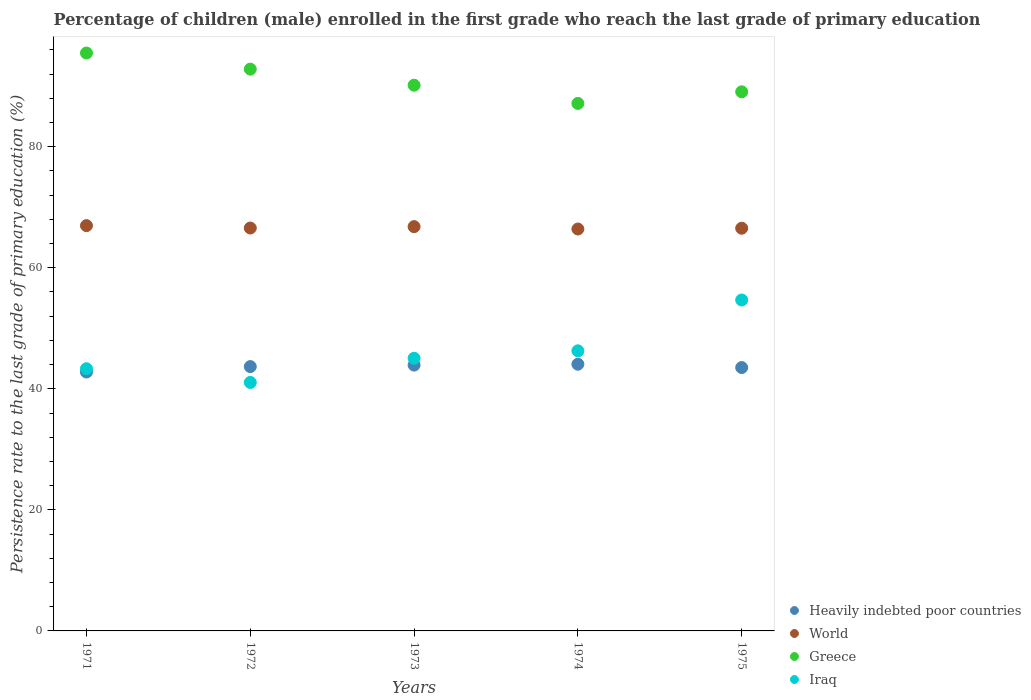What is the persistence rate of children in Iraq in 1973?
Provide a succinct answer. 45.05. Across all years, what is the maximum persistence rate of children in Greece?
Keep it short and to the point. 95.48. Across all years, what is the minimum persistence rate of children in Greece?
Provide a short and direct response. 87.15. In which year was the persistence rate of children in Iraq maximum?
Provide a succinct answer. 1975. In which year was the persistence rate of children in Greece minimum?
Give a very brief answer. 1974. What is the total persistence rate of children in Iraq in the graph?
Your response must be concise. 230.37. What is the difference between the persistence rate of children in World in 1972 and that in 1974?
Make the answer very short. 0.16. What is the difference between the persistence rate of children in Greece in 1971 and the persistence rate of children in World in 1974?
Provide a succinct answer. 29.07. What is the average persistence rate of children in World per year?
Make the answer very short. 66.65. In the year 1974, what is the difference between the persistence rate of children in Iraq and persistence rate of children in Heavily indebted poor countries?
Keep it short and to the point. 2.21. In how many years, is the persistence rate of children in Iraq greater than 76 %?
Offer a terse response. 0. What is the ratio of the persistence rate of children in Greece in 1972 to that in 1974?
Provide a succinct answer. 1.07. Is the difference between the persistence rate of children in Iraq in 1972 and 1974 greater than the difference between the persistence rate of children in Heavily indebted poor countries in 1972 and 1974?
Make the answer very short. No. What is the difference between the highest and the second highest persistence rate of children in Greece?
Make the answer very short. 2.66. What is the difference between the highest and the lowest persistence rate of children in Iraq?
Your response must be concise. 13.62. In how many years, is the persistence rate of children in Greece greater than the average persistence rate of children in Greece taken over all years?
Offer a very short reply. 2. Is it the case that in every year, the sum of the persistence rate of children in Iraq and persistence rate of children in Greece  is greater than the sum of persistence rate of children in World and persistence rate of children in Heavily indebted poor countries?
Your answer should be very brief. Yes. Does the persistence rate of children in Heavily indebted poor countries monotonically increase over the years?
Give a very brief answer. No. Is the persistence rate of children in Heavily indebted poor countries strictly less than the persistence rate of children in World over the years?
Your answer should be compact. Yes. How many dotlines are there?
Your response must be concise. 4. How many years are there in the graph?
Provide a short and direct response. 5. Are the values on the major ticks of Y-axis written in scientific E-notation?
Your answer should be very brief. No. Does the graph contain grids?
Provide a succinct answer. No. How many legend labels are there?
Your answer should be compact. 4. What is the title of the graph?
Make the answer very short. Percentage of children (male) enrolled in the first grade who reach the last grade of primary education. What is the label or title of the Y-axis?
Make the answer very short. Persistence rate to the last grade of primary education (%). What is the Persistence rate to the last grade of primary education (%) of Heavily indebted poor countries in 1971?
Give a very brief answer. 42.78. What is the Persistence rate to the last grade of primary education (%) in World in 1971?
Your answer should be very brief. 66.96. What is the Persistence rate to the last grade of primary education (%) of Greece in 1971?
Make the answer very short. 95.48. What is the Persistence rate to the last grade of primary education (%) in Iraq in 1971?
Keep it short and to the point. 43.32. What is the Persistence rate to the last grade of primary education (%) of Heavily indebted poor countries in 1972?
Your response must be concise. 43.67. What is the Persistence rate to the last grade of primary education (%) of World in 1972?
Offer a terse response. 66.57. What is the Persistence rate to the last grade of primary education (%) in Greece in 1972?
Your answer should be compact. 92.82. What is the Persistence rate to the last grade of primary education (%) in Iraq in 1972?
Make the answer very short. 41.05. What is the Persistence rate to the last grade of primary education (%) of Heavily indebted poor countries in 1973?
Give a very brief answer. 43.92. What is the Persistence rate to the last grade of primary education (%) of World in 1973?
Offer a terse response. 66.8. What is the Persistence rate to the last grade of primary education (%) of Greece in 1973?
Keep it short and to the point. 90.16. What is the Persistence rate to the last grade of primary education (%) in Iraq in 1973?
Provide a short and direct response. 45.05. What is the Persistence rate to the last grade of primary education (%) in Heavily indebted poor countries in 1974?
Your answer should be very brief. 44.07. What is the Persistence rate to the last grade of primary education (%) in World in 1974?
Your response must be concise. 66.41. What is the Persistence rate to the last grade of primary education (%) of Greece in 1974?
Your answer should be compact. 87.15. What is the Persistence rate to the last grade of primary education (%) in Iraq in 1974?
Make the answer very short. 46.28. What is the Persistence rate to the last grade of primary education (%) in Heavily indebted poor countries in 1975?
Provide a succinct answer. 43.51. What is the Persistence rate to the last grade of primary education (%) in World in 1975?
Offer a terse response. 66.53. What is the Persistence rate to the last grade of primary education (%) in Greece in 1975?
Make the answer very short. 89.07. What is the Persistence rate to the last grade of primary education (%) of Iraq in 1975?
Your answer should be compact. 54.68. Across all years, what is the maximum Persistence rate to the last grade of primary education (%) in Heavily indebted poor countries?
Ensure brevity in your answer.  44.07. Across all years, what is the maximum Persistence rate to the last grade of primary education (%) in World?
Make the answer very short. 66.96. Across all years, what is the maximum Persistence rate to the last grade of primary education (%) in Greece?
Give a very brief answer. 95.48. Across all years, what is the maximum Persistence rate to the last grade of primary education (%) in Iraq?
Ensure brevity in your answer.  54.68. Across all years, what is the minimum Persistence rate to the last grade of primary education (%) of Heavily indebted poor countries?
Provide a succinct answer. 42.78. Across all years, what is the minimum Persistence rate to the last grade of primary education (%) of World?
Provide a short and direct response. 66.41. Across all years, what is the minimum Persistence rate to the last grade of primary education (%) of Greece?
Your response must be concise. 87.15. Across all years, what is the minimum Persistence rate to the last grade of primary education (%) in Iraq?
Your answer should be compact. 41.05. What is the total Persistence rate to the last grade of primary education (%) of Heavily indebted poor countries in the graph?
Provide a succinct answer. 217.95. What is the total Persistence rate to the last grade of primary education (%) of World in the graph?
Make the answer very short. 333.26. What is the total Persistence rate to the last grade of primary education (%) in Greece in the graph?
Give a very brief answer. 454.68. What is the total Persistence rate to the last grade of primary education (%) of Iraq in the graph?
Provide a short and direct response. 230.37. What is the difference between the Persistence rate to the last grade of primary education (%) in Heavily indebted poor countries in 1971 and that in 1972?
Keep it short and to the point. -0.89. What is the difference between the Persistence rate to the last grade of primary education (%) of World in 1971 and that in 1972?
Keep it short and to the point. 0.39. What is the difference between the Persistence rate to the last grade of primary education (%) in Greece in 1971 and that in 1972?
Your response must be concise. 2.66. What is the difference between the Persistence rate to the last grade of primary education (%) of Iraq in 1971 and that in 1972?
Your answer should be very brief. 2.26. What is the difference between the Persistence rate to the last grade of primary education (%) of Heavily indebted poor countries in 1971 and that in 1973?
Ensure brevity in your answer.  -1.14. What is the difference between the Persistence rate to the last grade of primary education (%) of World in 1971 and that in 1973?
Provide a short and direct response. 0.16. What is the difference between the Persistence rate to the last grade of primary education (%) of Greece in 1971 and that in 1973?
Your response must be concise. 5.31. What is the difference between the Persistence rate to the last grade of primary education (%) in Iraq in 1971 and that in 1973?
Your answer should be compact. -1.73. What is the difference between the Persistence rate to the last grade of primary education (%) of Heavily indebted poor countries in 1971 and that in 1974?
Your answer should be very brief. -1.29. What is the difference between the Persistence rate to the last grade of primary education (%) in World in 1971 and that in 1974?
Ensure brevity in your answer.  0.56. What is the difference between the Persistence rate to the last grade of primary education (%) of Greece in 1971 and that in 1974?
Your response must be concise. 8.32. What is the difference between the Persistence rate to the last grade of primary education (%) in Iraq in 1971 and that in 1974?
Keep it short and to the point. -2.96. What is the difference between the Persistence rate to the last grade of primary education (%) in Heavily indebted poor countries in 1971 and that in 1975?
Your answer should be very brief. -0.73. What is the difference between the Persistence rate to the last grade of primary education (%) in World in 1971 and that in 1975?
Keep it short and to the point. 0.43. What is the difference between the Persistence rate to the last grade of primary education (%) of Greece in 1971 and that in 1975?
Offer a terse response. 6.41. What is the difference between the Persistence rate to the last grade of primary education (%) of Iraq in 1971 and that in 1975?
Ensure brevity in your answer.  -11.36. What is the difference between the Persistence rate to the last grade of primary education (%) of Heavily indebted poor countries in 1972 and that in 1973?
Your answer should be compact. -0.25. What is the difference between the Persistence rate to the last grade of primary education (%) of World in 1972 and that in 1973?
Your response must be concise. -0.23. What is the difference between the Persistence rate to the last grade of primary education (%) in Greece in 1972 and that in 1973?
Your response must be concise. 2.66. What is the difference between the Persistence rate to the last grade of primary education (%) in Iraq in 1972 and that in 1973?
Ensure brevity in your answer.  -3.99. What is the difference between the Persistence rate to the last grade of primary education (%) in Heavily indebted poor countries in 1972 and that in 1974?
Your answer should be compact. -0.39. What is the difference between the Persistence rate to the last grade of primary education (%) in World in 1972 and that in 1974?
Provide a short and direct response. 0.16. What is the difference between the Persistence rate to the last grade of primary education (%) of Greece in 1972 and that in 1974?
Ensure brevity in your answer.  5.67. What is the difference between the Persistence rate to the last grade of primary education (%) of Iraq in 1972 and that in 1974?
Keep it short and to the point. -5.22. What is the difference between the Persistence rate to the last grade of primary education (%) of Heavily indebted poor countries in 1972 and that in 1975?
Your answer should be compact. 0.16. What is the difference between the Persistence rate to the last grade of primary education (%) of World in 1972 and that in 1975?
Your response must be concise. 0.04. What is the difference between the Persistence rate to the last grade of primary education (%) in Greece in 1972 and that in 1975?
Your answer should be compact. 3.75. What is the difference between the Persistence rate to the last grade of primary education (%) of Iraq in 1972 and that in 1975?
Give a very brief answer. -13.62. What is the difference between the Persistence rate to the last grade of primary education (%) of Heavily indebted poor countries in 1973 and that in 1974?
Your answer should be compact. -0.15. What is the difference between the Persistence rate to the last grade of primary education (%) in World in 1973 and that in 1974?
Give a very brief answer. 0.39. What is the difference between the Persistence rate to the last grade of primary education (%) in Greece in 1973 and that in 1974?
Your answer should be compact. 3.01. What is the difference between the Persistence rate to the last grade of primary education (%) in Iraq in 1973 and that in 1974?
Your answer should be compact. -1.23. What is the difference between the Persistence rate to the last grade of primary education (%) in Heavily indebted poor countries in 1973 and that in 1975?
Offer a terse response. 0.41. What is the difference between the Persistence rate to the last grade of primary education (%) of World in 1973 and that in 1975?
Make the answer very short. 0.26. What is the difference between the Persistence rate to the last grade of primary education (%) in Greece in 1973 and that in 1975?
Make the answer very short. 1.09. What is the difference between the Persistence rate to the last grade of primary education (%) of Iraq in 1973 and that in 1975?
Give a very brief answer. -9.63. What is the difference between the Persistence rate to the last grade of primary education (%) in Heavily indebted poor countries in 1974 and that in 1975?
Make the answer very short. 0.56. What is the difference between the Persistence rate to the last grade of primary education (%) in World in 1974 and that in 1975?
Provide a succinct answer. -0.13. What is the difference between the Persistence rate to the last grade of primary education (%) of Greece in 1974 and that in 1975?
Make the answer very short. -1.92. What is the difference between the Persistence rate to the last grade of primary education (%) in Iraq in 1974 and that in 1975?
Your answer should be very brief. -8.4. What is the difference between the Persistence rate to the last grade of primary education (%) in Heavily indebted poor countries in 1971 and the Persistence rate to the last grade of primary education (%) in World in 1972?
Your answer should be compact. -23.79. What is the difference between the Persistence rate to the last grade of primary education (%) in Heavily indebted poor countries in 1971 and the Persistence rate to the last grade of primary education (%) in Greece in 1972?
Your answer should be very brief. -50.04. What is the difference between the Persistence rate to the last grade of primary education (%) in Heavily indebted poor countries in 1971 and the Persistence rate to the last grade of primary education (%) in Iraq in 1972?
Keep it short and to the point. 1.72. What is the difference between the Persistence rate to the last grade of primary education (%) of World in 1971 and the Persistence rate to the last grade of primary education (%) of Greece in 1972?
Your response must be concise. -25.86. What is the difference between the Persistence rate to the last grade of primary education (%) of World in 1971 and the Persistence rate to the last grade of primary education (%) of Iraq in 1972?
Your response must be concise. 25.91. What is the difference between the Persistence rate to the last grade of primary education (%) in Greece in 1971 and the Persistence rate to the last grade of primary education (%) in Iraq in 1972?
Offer a terse response. 54.42. What is the difference between the Persistence rate to the last grade of primary education (%) of Heavily indebted poor countries in 1971 and the Persistence rate to the last grade of primary education (%) of World in 1973?
Your answer should be very brief. -24.02. What is the difference between the Persistence rate to the last grade of primary education (%) in Heavily indebted poor countries in 1971 and the Persistence rate to the last grade of primary education (%) in Greece in 1973?
Your answer should be compact. -47.38. What is the difference between the Persistence rate to the last grade of primary education (%) of Heavily indebted poor countries in 1971 and the Persistence rate to the last grade of primary education (%) of Iraq in 1973?
Give a very brief answer. -2.27. What is the difference between the Persistence rate to the last grade of primary education (%) of World in 1971 and the Persistence rate to the last grade of primary education (%) of Greece in 1973?
Provide a short and direct response. -23.2. What is the difference between the Persistence rate to the last grade of primary education (%) of World in 1971 and the Persistence rate to the last grade of primary education (%) of Iraq in 1973?
Keep it short and to the point. 21.91. What is the difference between the Persistence rate to the last grade of primary education (%) of Greece in 1971 and the Persistence rate to the last grade of primary education (%) of Iraq in 1973?
Your response must be concise. 50.43. What is the difference between the Persistence rate to the last grade of primary education (%) of Heavily indebted poor countries in 1971 and the Persistence rate to the last grade of primary education (%) of World in 1974?
Ensure brevity in your answer.  -23.63. What is the difference between the Persistence rate to the last grade of primary education (%) in Heavily indebted poor countries in 1971 and the Persistence rate to the last grade of primary education (%) in Greece in 1974?
Give a very brief answer. -44.37. What is the difference between the Persistence rate to the last grade of primary education (%) of Heavily indebted poor countries in 1971 and the Persistence rate to the last grade of primary education (%) of Iraq in 1974?
Your answer should be very brief. -3.5. What is the difference between the Persistence rate to the last grade of primary education (%) in World in 1971 and the Persistence rate to the last grade of primary education (%) in Greece in 1974?
Keep it short and to the point. -20.19. What is the difference between the Persistence rate to the last grade of primary education (%) in World in 1971 and the Persistence rate to the last grade of primary education (%) in Iraq in 1974?
Make the answer very short. 20.68. What is the difference between the Persistence rate to the last grade of primary education (%) of Greece in 1971 and the Persistence rate to the last grade of primary education (%) of Iraq in 1974?
Provide a short and direct response. 49.2. What is the difference between the Persistence rate to the last grade of primary education (%) of Heavily indebted poor countries in 1971 and the Persistence rate to the last grade of primary education (%) of World in 1975?
Your answer should be very brief. -23.75. What is the difference between the Persistence rate to the last grade of primary education (%) in Heavily indebted poor countries in 1971 and the Persistence rate to the last grade of primary education (%) in Greece in 1975?
Your answer should be very brief. -46.29. What is the difference between the Persistence rate to the last grade of primary education (%) in Heavily indebted poor countries in 1971 and the Persistence rate to the last grade of primary education (%) in Iraq in 1975?
Give a very brief answer. -11.9. What is the difference between the Persistence rate to the last grade of primary education (%) of World in 1971 and the Persistence rate to the last grade of primary education (%) of Greece in 1975?
Offer a terse response. -22.11. What is the difference between the Persistence rate to the last grade of primary education (%) in World in 1971 and the Persistence rate to the last grade of primary education (%) in Iraq in 1975?
Provide a short and direct response. 12.29. What is the difference between the Persistence rate to the last grade of primary education (%) of Greece in 1971 and the Persistence rate to the last grade of primary education (%) of Iraq in 1975?
Provide a succinct answer. 40.8. What is the difference between the Persistence rate to the last grade of primary education (%) of Heavily indebted poor countries in 1972 and the Persistence rate to the last grade of primary education (%) of World in 1973?
Ensure brevity in your answer.  -23.12. What is the difference between the Persistence rate to the last grade of primary education (%) in Heavily indebted poor countries in 1972 and the Persistence rate to the last grade of primary education (%) in Greece in 1973?
Your answer should be very brief. -46.49. What is the difference between the Persistence rate to the last grade of primary education (%) of Heavily indebted poor countries in 1972 and the Persistence rate to the last grade of primary education (%) of Iraq in 1973?
Provide a succinct answer. -1.37. What is the difference between the Persistence rate to the last grade of primary education (%) of World in 1972 and the Persistence rate to the last grade of primary education (%) of Greece in 1973?
Keep it short and to the point. -23.6. What is the difference between the Persistence rate to the last grade of primary education (%) in World in 1972 and the Persistence rate to the last grade of primary education (%) in Iraq in 1973?
Ensure brevity in your answer.  21.52. What is the difference between the Persistence rate to the last grade of primary education (%) in Greece in 1972 and the Persistence rate to the last grade of primary education (%) in Iraq in 1973?
Make the answer very short. 47.77. What is the difference between the Persistence rate to the last grade of primary education (%) of Heavily indebted poor countries in 1972 and the Persistence rate to the last grade of primary education (%) of World in 1974?
Your response must be concise. -22.73. What is the difference between the Persistence rate to the last grade of primary education (%) in Heavily indebted poor countries in 1972 and the Persistence rate to the last grade of primary education (%) in Greece in 1974?
Keep it short and to the point. -43.48. What is the difference between the Persistence rate to the last grade of primary education (%) in Heavily indebted poor countries in 1972 and the Persistence rate to the last grade of primary education (%) in Iraq in 1974?
Provide a short and direct response. -2.61. What is the difference between the Persistence rate to the last grade of primary education (%) of World in 1972 and the Persistence rate to the last grade of primary education (%) of Greece in 1974?
Ensure brevity in your answer.  -20.59. What is the difference between the Persistence rate to the last grade of primary education (%) in World in 1972 and the Persistence rate to the last grade of primary education (%) in Iraq in 1974?
Ensure brevity in your answer.  20.29. What is the difference between the Persistence rate to the last grade of primary education (%) of Greece in 1972 and the Persistence rate to the last grade of primary education (%) of Iraq in 1974?
Offer a very short reply. 46.54. What is the difference between the Persistence rate to the last grade of primary education (%) in Heavily indebted poor countries in 1972 and the Persistence rate to the last grade of primary education (%) in World in 1975?
Your response must be concise. -22.86. What is the difference between the Persistence rate to the last grade of primary education (%) of Heavily indebted poor countries in 1972 and the Persistence rate to the last grade of primary education (%) of Greece in 1975?
Your response must be concise. -45.4. What is the difference between the Persistence rate to the last grade of primary education (%) in Heavily indebted poor countries in 1972 and the Persistence rate to the last grade of primary education (%) in Iraq in 1975?
Make the answer very short. -11. What is the difference between the Persistence rate to the last grade of primary education (%) of World in 1972 and the Persistence rate to the last grade of primary education (%) of Greece in 1975?
Keep it short and to the point. -22.5. What is the difference between the Persistence rate to the last grade of primary education (%) in World in 1972 and the Persistence rate to the last grade of primary education (%) in Iraq in 1975?
Your answer should be compact. 11.89. What is the difference between the Persistence rate to the last grade of primary education (%) in Greece in 1972 and the Persistence rate to the last grade of primary education (%) in Iraq in 1975?
Make the answer very short. 38.14. What is the difference between the Persistence rate to the last grade of primary education (%) in Heavily indebted poor countries in 1973 and the Persistence rate to the last grade of primary education (%) in World in 1974?
Provide a succinct answer. -22.49. What is the difference between the Persistence rate to the last grade of primary education (%) of Heavily indebted poor countries in 1973 and the Persistence rate to the last grade of primary education (%) of Greece in 1974?
Offer a terse response. -43.24. What is the difference between the Persistence rate to the last grade of primary education (%) of Heavily indebted poor countries in 1973 and the Persistence rate to the last grade of primary education (%) of Iraq in 1974?
Give a very brief answer. -2.36. What is the difference between the Persistence rate to the last grade of primary education (%) of World in 1973 and the Persistence rate to the last grade of primary education (%) of Greece in 1974?
Provide a short and direct response. -20.36. What is the difference between the Persistence rate to the last grade of primary education (%) in World in 1973 and the Persistence rate to the last grade of primary education (%) in Iraq in 1974?
Offer a very short reply. 20.52. What is the difference between the Persistence rate to the last grade of primary education (%) of Greece in 1973 and the Persistence rate to the last grade of primary education (%) of Iraq in 1974?
Your answer should be compact. 43.88. What is the difference between the Persistence rate to the last grade of primary education (%) in Heavily indebted poor countries in 1973 and the Persistence rate to the last grade of primary education (%) in World in 1975?
Provide a short and direct response. -22.61. What is the difference between the Persistence rate to the last grade of primary education (%) in Heavily indebted poor countries in 1973 and the Persistence rate to the last grade of primary education (%) in Greece in 1975?
Your answer should be very brief. -45.15. What is the difference between the Persistence rate to the last grade of primary education (%) in Heavily indebted poor countries in 1973 and the Persistence rate to the last grade of primary education (%) in Iraq in 1975?
Your answer should be compact. -10.76. What is the difference between the Persistence rate to the last grade of primary education (%) of World in 1973 and the Persistence rate to the last grade of primary education (%) of Greece in 1975?
Your answer should be very brief. -22.27. What is the difference between the Persistence rate to the last grade of primary education (%) in World in 1973 and the Persistence rate to the last grade of primary education (%) in Iraq in 1975?
Offer a very short reply. 12.12. What is the difference between the Persistence rate to the last grade of primary education (%) in Greece in 1973 and the Persistence rate to the last grade of primary education (%) in Iraq in 1975?
Keep it short and to the point. 35.49. What is the difference between the Persistence rate to the last grade of primary education (%) of Heavily indebted poor countries in 1974 and the Persistence rate to the last grade of primary education (%) of World in 1975?
Provide a succinct answer. -22.47. What is the difference between the Persistence rate to the last grade of primary education (%) in Heavily indebted poor countries in 1974 and the Persistence rate to the last grade of primary education (%) in Greece in 1975?
Offer a very short reply. -45. What is the difference between the Persistence rate to the last grade of primary education (%) of Heavily indebted poor countries in 1974 and the Persistence rate to the last grade of primary education (%) of Iraq in 1975?
Provide a short and direct response. -10.61. What is the difference between the Persistence rate to the last grade of primary education (%) of World in 1974 and the Persistence rate to the last grade of primary education (%) of Greece in 1975?
Keep it short and to the point. -22.67. What is the difference between the Persistence rate to the last grade of primary education (%) in World in 1974 and the Persistence rate to the last grade of primary education (%) in Iraq in 1975?
Your response must be concise. 11.73. What is the difference between the Persistence rate to the last grade of primary education (%) in Greece in 1974 and the Persistence rate to the last grade of primary education (%) in Iraq in 1975?
Provide a succinct answer. 32.48. What is the average Persistence rate to the last grade of primary education (%) of Heavily indebted poor countries per year?
Your answer should be very brief. 43.59. What is the average Persistence rate to the last grade of primary education (%) of World per year?
Give a very brief answer. 66.65. What is the average Persistence rate to the last grade of primary education (%) of Greece per year?
Provide a succinct answer. 90.94. What is the average Persistence rate to the last grade of primary education (%) of Iraq per year?
Your answer should be very brief. 46.07. In the year 1971, what is the difference between the Persistence rate to the last grade of primary education (%) of Heavily indebted poor countries and Persistence rate to the last grade of primary education (%) of World?
Offer a very short reply. -24.18. In the year 1971, what is the difference between the Persistence rate to the last grade of primary education (%) in Heavily indebted poor countries and Persistence rate to the last grade of primary education (%) in Greece?
Give a very brief answer. -52.7. In the year 1971, what is the difference between the Persistence rate to the last grade of primary education (%) of Heavily indebted poor countries and Persistence rate to the last grade of primary education (%) of Iraq?
Make the answer very short. -0.54. In the year 1971, what is the difference between the Persistence rate to the last grade of primary education (%) in World and Persistence rate to the last grade of primary education (%) in Greece?
Offer a very short reply. -28.52. In the year 1971, what is the difference between the Persistence rate to the last grade of primary education (%) in World and Persistence rate to the last grade of primary education (%) in Iraq?
Offer a very short reply. 23.64. In the year 1971, what is the difference between the Persistence rate to the last grade of primary education (%) in Greece and Persistence rate to the last grade of primary education (%) in Iraq?
Give a very brief answer. 52.16. In the year 1972, what is the difference between the Persistence rate to the last grade of primary education (%) of Heavily indebted poor countries and Persistence rate to the last grade of primary education (%) of World?
Provide a succinct answer. -22.89. In the year 1972, what is the difference between the Persistence rate to the last grade of primary education (%) of Heavily indebted poor countries and Persistence rate to the last grade of primary education (%) of Greece?
Make the answer very short. -49.15. In the year 1972, what is the difference between the Persistence rate to the last grade of primary education (%) in Heavily indebted poor countries and Persistence rate to the last grade of primary education (%) in Iraq?
Your response must be concise. 2.62. In the year 1972, what is the difference between the Persistence rate to the last grade of primary education (%) of World and Persistence rate to the last grade of primary education (%) of Greece?
Keep it short and to the point. -26.25. In the year 1972, what is the difference between the Persistence rate to the last grade of primary education (%) of World and Persistence rate to the last grade of primary education (%) of Iraq?
Ensure brevity in your answer.  25.51. In the year 1972, what is the difference between the Persistence rate to the last grade of primary education (%) in Greece and Persistence rate to the last grade of primary education (%) in Iraq?
Make the answer very short. 51.77. In the year 1973, what is the difference between the Persistence rate to the last grade of primary education (%) of Heavily indebted poor countries and Persistence rate to the last grade of primary education (%) of World?
Offer a very short reply. -22.88. In the year 1973, what is the difference between the Persistence rate to the last grade of primary education (%) of Heavily indebted poor countries and Persistence rate to the last grade of primary education (%) of Greece?
Offer a very short reply. -46.24. In the year 1973, what is the difference between the Persistence rate to the last grade of primary education (%) in Heavily indebted poor countries and Persistence rate to the last grade of primary education (%) in Iraq?
Your response must be concise. -1.13. In the year 1973, what is the difference between the Persistence rate to the last grade of primary education (%) in World and Persistence rate to the last grade of primary education (%) in Greece?
Ensure brevity in your answer.  -23.37. In the year 1973, what is the difference between the Persistence rate to the last grade of primary education (%) of World and Persistence rate to the last grade of primary education (%) of Iraq?
Your response must be concise. 21.75. In the year 1973, what is the difference between the Persistence rate to the last grade of primary education (%) of Greece and Persistence rate to the last grade of primary education (%) of Iraq?
Ensure brevity in your answer.  45.12. In the year 1974, what is the difference between the Persistence rate to the last grade of primary education (%) in Heavily indebted poor countries and Persistence rate to the last grade of primary education (%) in World?
Offer a very short reply. -22.34. In the year 1974, what is the difference between the Persistence rate to the last grade of primary education (%) of Heavily indebted poor countries and Persistence rate to the last grade of primary education (%) of Greece?
Give a very brief answer. -43.09. In the year 1974, what is the difference between the Persistence rate to the last grade of primary education (%) of Heavily indebted poor countries and Persistence rate to the last grade of primary education (%) of Iraq?
Offer a very short reply. -2.21. In the year 1974, what is the difference between the Persistence rate to the last grade of primary education (%) in World and Persistence rate to the last grade of primary education (%) in Greece?
Provide a succinct answer. -20.75. In the year 1974, what is the difference between the Persistence rate to the last grade of primary education (%) of World and Persistence rate to the last grade of primary education (%) of Iraq?
Provide a short and direct response. 20.13. In the year 1974, what is the difference between the Persistence rate to the last grade of primary education (%) of Greece and Persistence rate to the last grade of primary education (%) of Iraq?
Offer a very short reply. 40.87. In the year 1975, what is the difference between the Persistence rate to the last grade of primary education (%) of Heavily indebted poor countries and Persistence rate to the last grade of primary education (%) of World?
Your answer should be compact. -23.02. In the year 1975, what is the difference between the Persistence rate to the last grade of primary education (%) in Heavily indebted poor countries and Persistence rate to the last grade of primary education (%) in Greece?
Provide a short and direct response. -45.56. In the year 1975, what is the difference between the Persistence rate to the last grade of primary education (%) in Heavily indebted poor countries and Persistence rate to the last grade of primary education (%) in Iraq?
Provide a succinct answer. -11.16. In the year 1975, what is the difference between the Persistence rate to the last grade of primary education (%) in World and Persistence rate to the last grade of primary education (%) in Greece?
Your answer should be very brief. -22.54. In the year 1975, what is the difference between the Persistence rate to the last grade of primary education (%) in World and Persistence rate to the last grade of primary education (%) in Iraq?
Provide a short and direct response. 11.86. In the year 1975, what is the difference between the Persistence rate to the last grade of primary education (%) in Greece and Persistence rate to the last grade of primary education (%) in Iraq?
Provide a succinct answer. 34.4. What is the ratio of the Persistence rate to the last grade of primary education (%) of Heavily indebted poor countries in 1971 to that in 1972?
Provide a succinct answer. 0.98. What is the ratio of the Persistence rate to the last grade of primary education (%) of World in 1971 to that in 1972?
Your answer should be compact. 1.01. What is the ratio of the Persistence rate to the last grade of primary education (%) of Greece in 1971 to that in 1972?
Offer a very short reply. 1.03. What is the ratio of the Persistence rate to the last grade of primary education (%) in Iraq in 1971 to that in 1972?
Provide a succinct answer. 1.06. What is the ratio of the Persistence rate to the last grade of primary education (%) of Heavily indebted poor countries in 1971 to that in 1973?
Your answer should be very brief. 0.97. What is the ratio of the Persistence rate to the last grade of primary education (%) of World in 1971 to that in 1973?
Ensure brevity in your answer.  1. What is the ratio of the Persistence rate to the last grade of primary education (%) in Greece in 1971 to that in 1973?
Offer a very short reply. 1.06. What is the ratio of the Persistence rate to the last grade of primary education (%) of Iraq in 1971 to that in 1973?
Make the answer very short. 0.96. What is the ratio of the Persistence rate to the last grade of primary education (%) in Heavily indebted poor countries in 1971 to that in 1974?
Your response must be concise. 0.97. What is the ratio of the Persistence rate to the last grade of primary education (%) of World in 1971 to that in 1974?
Your response must be concise. 1.01. What is the ratio of the Persistence rate to the last grade of primary education (%) in Greece in 1971 to that in 1974?
Offer a terse response. 1.1. What is the ratio of the Persistence rate to the last grade of primary education (%) in Iraq in 1971 to that in 1974?
Provide a short and direct response. 0.94. What is the ratio of the Persistence rate to the last grade of primary education (%) of Heavily indebted poor countries in 1971 to that in 1975?
Give a very brief answer. 0.98. What is the ratio of the Persistence rate to the last grade of primary education (%) of World in 1971 to that in 1975?
Your answer should be compact. 1.01. What is the ratio of the Persistence rate to the last grade of primary education (%) in Greece in 1971 to that in 1975?
Your answer should be very brief. 1.07. What is the ratio of the Persistence rate to the last grade of primary education (%) of Iraq in 1971 to that in 1975?
Offer a terse response. 0.79. What is the ratio of the Persistence rate to the last grade of primary education (%) in Greece in 1972 to that in 1973?
Your answer should be very brief. 1.03. What is the ratio of the Persistence rate to the last grade of primary education (%) in Iraq in 1972 to that in 1973?
Provide a succinct answer. 0.91. What is the ratio of the Persistence rate to the last grade of primary education (%) of Heavily indebted poor countries in 1972 to that in 1974?
Your answer should be compact. 0.99. What is the ratio of the Persistence rate to the last grade of primary education (%) of Greece in 1972 to that in 1974?
Provide a short and direct response. 1.06. What is the ratio of the Persistence rate to the last grade of primary education (%) in Iraq in 1972 to that in 1974?
Give a very brief answer. 0.89. What is the ratio of the Persistence rate to the last grade of primary education (%) of World in 1972 to that in 1975?
Offer a very short reply. 1. What is the ratio of the Persistence rate to the last grade of primary education (%) in Greece in 1972 to that in 1975?
Keep it short and to the point. 1.04. What is the ratio of the Persistence rate to the last grade of primary education (%) in Iraq in 1972 to that in 1975?
Provide a short and direct response. 0.75. What is the ratio of the Persistence rate to the last grade of primary education (%) of World in 1973 to that in 1974?
Keep it short and to the point. 1.01. What is the ratio of the Persistence rate to the last grade of primary education (%) in Greece in 1973 to that in 1974?
Offer a very short reply. 1.03. What is the ratio of the Persistence rate to the last grade of primary education (%) in Iraq in 1973 to that in 1974?
Offer a very short reply. 0.97. What is the ratio of the Persistence rate to the last grade of primary education (%) in Heavily indebted poor countries in 1973 to that in 1975?
Offer a very short reply. 1.01. What is the ratio of the Persistence rate to the last grade of primary education (%) of World in 1973 to that in 1975?
Your answer should be very brief. 1. What is the ratio of the Persistence rate to the last grade of primary education (%) of Greece in 1973 to that in 1975?
Give a very brief answer. 1.01. What is the ratio of the Persistence rate to the last grade of primary education (%) of Iraq in 1973 to that in 1975?
Your response must be concise. 0.82. What is the ratio of the Persistence rate to the last grade of primary education (%) in Heavily indebted poor countries in 1974 to that in 1975?
Provide a succinct answer. 1.01. What is the ratio of the Persistence rate to the last grade of primary education (%) of Greece in 1974 to that in 1975?
Ensure brevity in your answer.  0.98. What is the ratio of the Persistence rate to the last grade of primary education (%) in Iraq in 1974 to that in 1975?
Give a very brief answer. 0.85. What is the difference between the highest and the second highest Persistence rate to the last grade of primary education (%) in Heavily indebted poor countries?
Provide a succinct answer. 0.15. What is the difference between the highest and the second highest Persistence rate to the last grade of primary education (%) of World?
Your response must be concise. 0.16. What is the difference between the highest and the second highest Persistence rate to the last grade of primary education (%) in Greece?
Offer a very short reply. 2.66. What is the difference between the highest and the second highest Persistence rate to the last grade of primary education (%) of Iraq?
Keep it short and to the point. 8.4. What is the difference between the highest and the lowest Persistence rate to the last grade of primary education (%) of Heavily indebted poor countries?
Your response must be concise. 1.29. What is the difference between the highest and the lowest Persistence rate to the last grade of primary education (%) of World?
Your response must be concise. 0.56. What is the difference between the highest and the lowest Persistence rate to the last grade of primary education (%) of Greece?
Give a very brief answer. 8.32. What is the difference between the highest and the lowest Persistence rate to the last grade of primary education (%) of Iraq?
Make the answer very short. 13.62. 